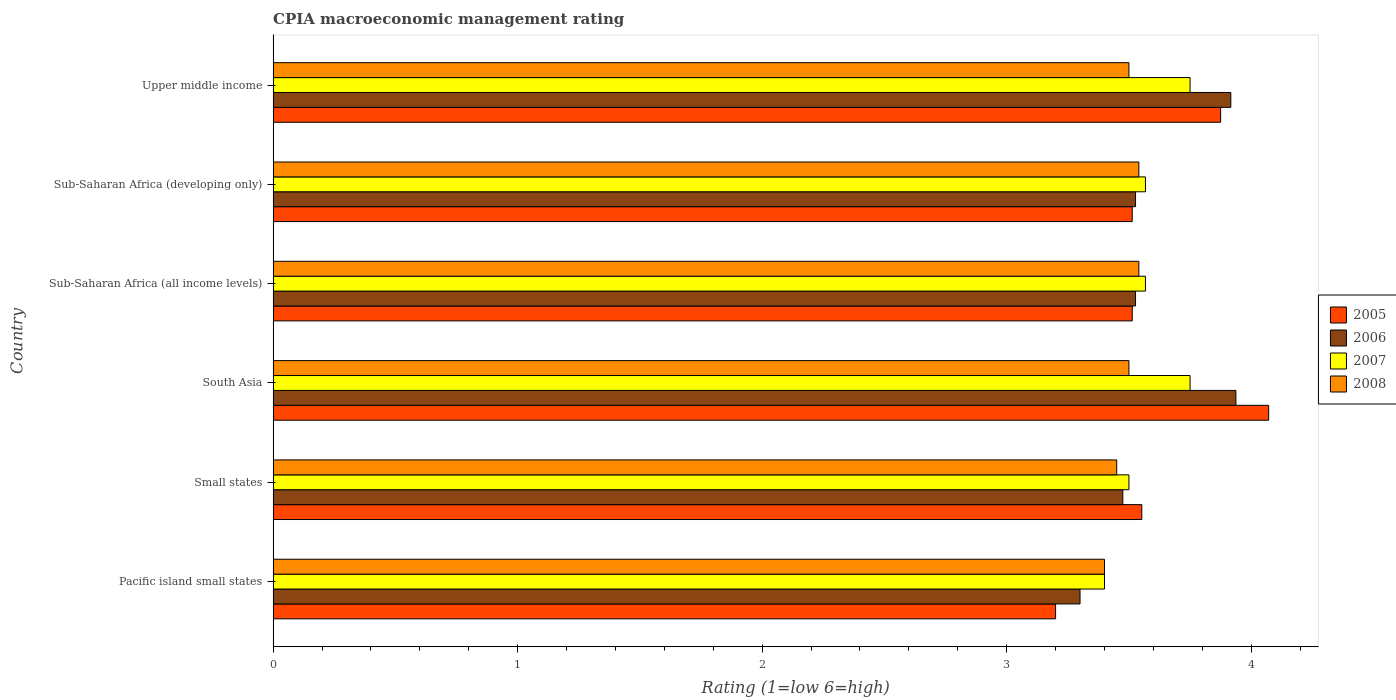How many groups of bars are there?
Keep it short and to the point. 6. Are the number of bars per tick equal to the number of legend labels?
Offer a very short reply. Yes. How many bars are there on the 3rd tick from the top?
Give a very brief answer. 4. How many bars are there on the 5th tick from the bottom?
Keep it short and to the point. 4. What is the label of the 2nd group of bars from the top?
Make the answer very short. Sub-Saharan Africa (developing only). What is the CPIA rating in 2005 in Sub-Saharan Africa (developing only)?
Ensure brevity in your answer.  3.51. Across all countries, what is the maximum CPIA rating in 2007?
Give a very brief answer. 3.75. Across all countries, what is the minimum CPIA rating in 2007?
Your answer should be compact. 3.4. In which country was the CPIA rating in 2005 maximum?
Make the answer very short. South Asia. In which country was the CPIA rating in 2005 minimum?
Ensure brevity in your answer.  Pacific island small states. What is the total CPIA rating in 2007 in the graph?
Keep it short and to the point. 21.54. What is the difference between the CPIA rating in 2005 in Sub-Saharan Africa (all income levels) and that in Upper middle income?
Give a very brief answer. -0.36. What is the difference between the CPIA rating in 2008 in Pacific island small states and the CPIA rating in 2006 in South Asia?
Your answer should be very brief. -0.54. What is the average CPIA rating in 2005 per country?
Provide a short and direct response. 3.62. What is the difference between the CPIA rating in 2007 and CPIA rating in 2006 in Small states?
Provide a succinct answer. 0.02. In how many countries, is the CPIA rating in 2008 greater than 0.6000000000000001 ?
Keep it short and to the point. 6. What is the ratio of the CPIA rating in 2006 in Sub-Saharan Africa (all income levels) to that in Upper middle income?
Provide a short and direct response. 0.9. Is the difference between the CPIA rating in 2007 in Sub-Saharan Africa (developing only) and Upper middle income greater than the difference between the CPIA rating in 2006 in Sub-Saharan Africa (developing only) and Upper middle income?
Your answer should be compact. Yes. What is the difference between the highest and the second highest CPIA rating in 2005?
Your response must be concise. 0.2. What is the difference between the highest and the lowest CPIA rating in 2006?
Make the answer very short. 0.64. In how many countries, is the CPIA rating in 2007 greater than the average CPIA rating in 2007 taken over all countries?
Ensure brevity in your answer.  2. Is the sum of the CPIA rating in 2006 in South Asia and Sub-Saharan Africa (developing only) greater than the maximum CPIA rating in 2007 across all countries?
Your answer should be compact. Yes. What does the 2nd bar from the bottom in Pacific island small states represents?
Keep it short and to the point. 2006. Are all the bars in the graph horizontal?
Ensure brevity in your answer.  Yes. What is the difference between two consecutive major ticks on the X-axis?
Ensure brevity in your answer.  1. Are the values on the major ticks of X-axis written in scientific E-notation?
Provide a short and direct response. No. Does the graph contain any zero values?
Offer a very short reply. No. Does the graph contain grids?
Provide a succinct answer. No. How are the legend labels stacked?
Provide a short and direct response. Vertical. What is the title of the graph?
Your answer should be compact. CPIA macroeconomic management rating. Does "1964" appear as one of the legend labels in the graph?
Provide a succinct answer. No. What is the label or title of the Y-axis?
Your response must be concise. Country. What is the Rating (1=low 6=high) of 2006 in Pacific island small states?
Your response must be concise. 3.3. What is the Rating (1=low 6=high) of 2008 in Pacific island small states?
Offer a terse response. 3.4. What is the Rating (1=low 6=high) of 2005 in Small states?
Provide a succinct answer. 3.55. What is the Rating (1=low 6=high) of 2006 in Small states?
Offer a very short reply. 3.48. What is the Rating (1=low 6=high) of 2008 in Small states?
Your answer should be very brief. 3.45. What is the Rating (1=low 6=high) in 2005 in South Asia?
Your answer should be compact. 4.07. What is the Rating (1=low 6=high) in 2006 in South Asia?
Provide a succinct answer. 3.94. What is the Rating (1=low 6=high) of 2007 in South Asia?
Your response must be concise. 3.75. What is the Rating (1=low 6=high) of 2005 in Sub-Saharan Africa (all income levels)?
Give a very brief answer. 3.51. What is the Rating (1=low 6=high) in 2006 in Sub-Saharan Africa (all income levels)?
Make the answer very short. 3.53. What is the Rating (1=low 6=high) in 2007 in Sub-Saharan Africa (all income levels)?
Offer a very short reply. 3.57. What is the Rating (1=low 6=high) in 2008 in Sub-Saharan Africa (all income levels)?
Provide a short and direct response. 3.54. What is the Rating (1=low 6=high) of 2005 in Sub-Saharan Africa (developing only)?
Give a very brief answer. 3.51. What is the Rating (1=low 6=high) of 2006 in Sub-Saharan Africa (developing only)?
Your answer should be very brief. 3.53. What is the Rating (1=low 6=high) in 2007 in Sub-Saharan Africa (developing only)?
Offer a terse response. 3.57. What is the Rating (1=low 6=high) in 2008 in Sub-Saharan Africa (developing only)?
Provide a succinct answer. 3.54. What is the Rating (1=low 6=high) in 2005 in Upper middle income?
Your response must be concise. 3.88. What is the Rating (1=low 6=high) of 2006 in Upper middle income?
Give a very brief answer. 3.92. What is the Rating (1=low 6=high) of 2007 in Upper middle income?
Make the answer very short. 3.75. Across all countries, what is the maximum Rating (1=low 6=high) of 2005?
Offer a terse response. 4.07. Across all countries, what is the maximum Rating (1=low 6=high) of 2006?
Your answer should be compact. 3.94. Across all countries, what is the maximum Rating (1=low 6=high) of 2007?
Your response must be concise. 3.75. Across all countries, what is the maximum Rating (1=low 6=high) in 2008?
Your answer should be very brief. 3.54. Across all countries, what is the minimum Rating (1=low 6=high) in 2008?
Give a very brief answer. 3.4. What is the total Rating (1=low 6=high) in 2005 in the graph?
Your response must be concise. 21.73. What is the total Rating (1=low 6=high) in 2006 in the graph?
Ensure brevity in your answer.  21.68. What is the total Rating (1=low 6=high) in 2007 in the graph?
Provide a short and direct response. 21.54. What is the total Rating (1=low 6=high) in 2008 in the graph?
Your answer should be very brief. 20.93. What is the difference between the Rating (1=low 6=high) of 2005 in Pacific island small states and that in Small states?
Make the answer very short. -0.35. What is the difference between the Rating (1=low 6=high) in 2006 in Pacific island small states and that in Small states?
Make the answer very short. -0.17. What is the difference between the Rating (1=low 6=high) of 2007 in Pacific island small states and that in Small states?
Your answer should be compact. -0.1. What is the difference between the Rating (1=low 6=high) in 2008 in Pacific island small states and that in Small states?
Ensure brevity in your answer.  -0.05. What is the difference between the Rating (1=low 6=high) in 2005 in Pacific island small states and that in South Asia?
Give a very brief answer. -0.87. What is the difference between the Rating (1=low 6=high) in 2006 in Pacific island small states and that in South Asia?
Ensure brevity in your answer.  -0.64. What is the difference between the Rating (1=low 6=high) in 2007 in Pacific island small states and that in South Asia?
Your answer should be very brief. -0.35. What is the difference between the Rating (1=low 6=high) in 2008 in Pacific island small states and that in South Asia?
Make the answer very short. -0.1. What is the difference between the Rating (1=low 6=high) in 2005 in Pacific island small states and that in Sub-Saharan Africa (all income levels)?
Keep it short and to the point. -0.31. What is the difference between the Rating (1=low 6=high) in 2006 in Pacific island small states and that in Sub-Saharan Africa (all income levels)?
Your answer should be compact. -0.23. What is the difference between the Rating (1=low 6=high) in 2007 in Pacific island small states and that in Sub-Saharan Africa (all income levels)?
Your response must be concise. -0.17. What is the difference between the Rating (1=low 6=high) in 2008 in Pacific island small states and that in Sub-Saharan Africa (all income levels)?
Make the answer very short. -0.14. What is the difference between the Rating (1=low 6=high) of 2005 in Pacific island small states and that in Sub-Saharan Africa (developing only)?
Your answer should be very brief. -0.31. What is the difference between the Rating (1=low 6=high) of 2006 in Pacific island small states and that in Sub-Saharan Africa (developing only)?
Your answer should be very brief. -0.23. What is the difference between the Rating (1=low 6=high) of 2007 in Pacific island small states and that in Sub-Saharan Africa (developing only)?
Offer a terse response. -0.17. What is the difference between the Rating (1=low 6=high) of 2008 in Pacific island small states and that in Sub-Saharan Africa (developing only)?
Ensure brevity in your answer.  -0.14. What is the difference between the Rating (1=low 6=high) of 2005 in Pacific island small states and that in Upper middle income?
Provide a succinct answer. -0.68. What is the difference between the Rating (1=low 6=high) of 2006 in Pacific island small states and that in Upper middle income?
Your answer should be very brief. -0.62. What is the difference between the Rating (1=low 6=high) of 2007 in Pacific island small states and that in Upper middle income?
Offer a terse response. -0.35. What is the difference between the Rating (1=low 6=high) of 2008 in Pacific island small states and that in Upper middle income?
Give a very brief answer. -0.1. What is the difference between the Rating (1=low 6=high) of 2005 in Small states and that in South Asia?
Your answer should be very brief. -0.52. What is the difference between the Rating (1=low 6=high) in 2006 in Small states and that in South Asia?
Your answer should be compact. -0.46. What is the difference between the Rating (1=low 6=high) in 2008 in Small states and that in South Asia?
Offer a terse response. -0.05. What is the difference between the Rating (1=low 6=high) in 2005 in Small states and that in Sub-Saharan Africa (all income levels)?
Provide a succinct answer. 0.04. What is the difference between the Rating (1=low 6=high) of 2006 in Small states and that in Sub-Saharan Africa (all income levels)?
Provide a short and direct response. -0.05. What is the difference between the Rating (1=low 6=high) in 2007 in Small states and that in Sub-Saharan Africa (all income levels)?
Your answer should be compact. -0.07. What is the difference between the Rating (1=low 6=high) of 2008 in Small states and that in Sub-Saharan Africa (all income levels)?
Provide a short and direct response. -0.09. What is the difference between the Rating (1=low 6=high) in 2005 in Small states and that in Sub-Saharan Africa (developing only)?
Your answer should be very brief. 0.04. What is the difference between the Rating (1=low 6=high) of 2006 in Small states and that in Sub-Saharan Africa (developing only)?
Provide a short and direct response. -0.05. What is the difference between the Rating (1=low 6=high) in 2007 in Small states and that in Sub-Saharan Africa (developing only)?
Offer a terse response. -0.07. What is the difference between the Rating (1=low 6=high) in 2008 in Small states and that in Sub-Saharan Africa (developing only)?
Give a very brief answer. -0.09. What is the difference between the Rating (1=low 6=high) of 2005 in Small states and that in Upper middle income?
Your answer should be very brief. -0.32. What is the difference between the Rating (1=low 6=high) in 2006 in Small states and that in Upper middle income?
Ensure brevity in your answer.  -0.44. What is the difference between the Rating (1=low 6=high) in 2005 in South Asia and that in Sub-Saharan Africa (all income levels)?
Provide a succinct answer. 0.56. What is the difference between the Rating (1=low 6=high) of 2006 in South Asia and that in Sub-Saharan Africa (all income levels)?
Give a very brief answer. 0.41. What is the difference between the Rating (1=low 6=high) in 2007 in South Asia and that in Sub-Saharan Africa (all income levels)?
Make the answer very short. 0.18. What is the difference between the Rating (1=low 6=high) in 2008 in South Asia and that in Sub-Saharan Africa (all income levels)?
Give a very brief answer. -0.04. What is the difference between the Rating (1=low 6=high) of 2005 in South Asia and that in Sub-Saharan Africa (developing only)?
Your answer should be very brief. 0.56. What is the difference between the Rating (1=low 6=high) of 2006 in South Asia and that in Sub-Saharan Africa (developing only)?
Provide a succinct answer. 0.41. What is the difference between the Rating (1=low 6=high) of 2007 in South Asia and that in Sub-Saharan Africa (developing only)?
Ensure brevity in your answer.  0.18. What is the difference between the Rating (1=low 6=high) of 2008 in South Asia and that in Sub-Saharan Africa (developing only)?
Offer a terse response. -0.04. What is the difference between the Rating (1=low 6=high) of 2005 in South Asia and that in Upper middle income?
Your answer should be very brief. 0.2. What is the difference between the Rating (1=low 6=high) in 2006 in South Asia and that in Upper middle income?
Keep it short and to the point. 0.02. What is the difference between the Rating (1=low 6=high) in 2008 in South Asia and that in Upper middle income?
Keep it short and to the point. 0. What is the difference between the Rating (1=low 6=high) of 2005 in Sub-Saharan Africa (all income levels) and that in Upper middle income?
Make the answer very short. -0.36. What is the difference between the Rating (1=low 6=high) in 2006 in Sub-Saharan Africa (all income levels) and that in Upper middle income?
Keep it short and to the point. -0.39. What is the difference between the Rating (1=low 6=high) of 2007 in Sub-Saharan Africa (all income levels) and that in Upper middle income?
Your answer should be very brief. -0.18. What is the difference between the Rating (1=low 6=high) of 2008 in Sub-Saharan Africa (all income levels) and that in Upper middle income?
Offer a terse response. 0.04. What is the difference between the Rating (1=low 6=high) in 2005 in Sub-Saharan Africa (developing only) and that in Upper middle income?
Make the answer very short. -0.36. What is the difference between the Rating (1=low 6=high) in 2006 in Sub-Saharan Africa (developing only) and that in Upper middle income?
Give a very brief answer. -0.39. What is the difference between the Rating (1=low 6=high) of 2007 in Sub-Saharan Africa (developing only) and that in Upper middle income?
Give a very brief answer. -0.18. What is the difference between the Rating (1=low 6=high) of 2008 in Sub-Saharan Africa (developing only) and that in Upper middle income?
Your answer should be compact. 0.04. What is the difference between the Rating (1=low 6=high) in 2005 in Pacific island small states and the Rating (1=low 6=high) in 2006 in Small states?
Ensure brevity in your answer.  -0.28. What is the difference between the Rating (1=low 6=high) of 2005 in Pacific island small states and the Rating (1=low 6=high) of 2008 in Small states?
Provide a succinct answer. -0.25. What is the difference between the Rating (1=low 6=high) of 2006 in Pacific island small states and the Rating (1=low 6=high) of 2008 in Small states?
Give a very brief answer. -0.15. What is the difference between the Rating (1=low 6=high) in 2007 in Pacific island small states and the Rating (1=low 6=high) in 2008 in Small states?
Your answer should be very brief. -0.05. What is the difference between the Rating (1=low 6=high) of 2005 in Pacific island small states and the Rating (1=low 6=high) of 2006 in South Asia?
Ensure brevity in your answer.  -0.74. What is the difference between the Rating (1=low 6=high) of 2005 in Pacific island small states and the Rating (1=low 6=high) of 2007 in South Asia?
Your answer should be very brief. -0.55. What is the difference between the Rating (1=low 6=high) in 2005 in Pacific island small states and the Rating (1=low 6=high) in 2008 in South Asia?
Your answer should be compact. -0.3. What is the difference between the Rating (1=low 6=high) in 2006 in Pacific island small states and the Rating (1=low 6=high) in 2007 in South Asia?
Offer a terse response. -0.45. What is the difference between the Rating (1=low 6=high) in 2005 in Pacific island small states and the Rating (1=low 6=high) in 2006 in Sub-Saharan Africa (all income levels)?
Offer a terse response. -0.33. What is the difference between the Rating (1=low 6=high) in 2005 in Pacific island small states and the Rating (1=low 6=high) in 2007 in Sub-Saharan Africa (all income levels)?
Offer a terse response. -0.37. What is the difference between the Rating (1=low 6=high) in 2005 in Pacific island small states and the Rating (1=low 6=high) in 2008 in Sub-Saharan Africa (all income levels)?
Give a very brief answer. -0.34. What is the difference between the Rating (1=low 6=high) of 2006 in Pacific island small states and the Rating (1=low 6=high) of 2007 in Sub-Saharan Africa (all income levels)?
Offer a terse response. -0.27. What is the difference between the Rating (1=low 6=high) of 2006 in Pacific island small states and the Rating (1=low 6=high) of 2008 in Sub-Saharan Africa (all income levels)?
Ensure brevity in your answer.  -0.24. What is the difference between the Rating (1=low 6=high) in 2007 in Pacific island small states and the Rating (1=low 6=high) in 2008 in Sub-Saharan Africa (all income levels)?
Offer a very short reply. -0.14. What is the difference between the Rating (1=low 6=high) in 2005 in Pacific island small states and the Rating (1=low 6=high) in 2006 in Sub-Saharan Africa (developing only)?
Give a very brief answer. -0.33. What is the difference between the Rating (1=low 6=high) in 2005 in Pacific island small states and the Rating (1=low 6=high) in 2007 in Sub-Saharan Africa (developing only)?
Provide a succinct answer. -0.37. What is the difference between the Rating (1=low 6=high) in 2005 in Pacific island small states and the Rating (1=low 6=high) in 2008 in Sub-Saharan Africa (developing only)?
Offer a terse response. -0.34. What is the difference between the Rating (1=low 6=high) in 2006 in Pacific island small states and the Rating (1=low 6=high) in 2007 in Sub-Saharan Africa (developing only)?
Your answer should be compact. -0.27. What is the difference between the Rating (1=low 6=high) of 2006 in Pacific island small states and the Rating (1=low 6=high) of 2008 in Sub-Saharan Africa (developing only)?
Ensure brevity in your answer.  -0.24. What is the difference between the Rating (1=low 6=high) of 2007 in Pacific island small states and the Rating (1=low 6=high) of 2008 in Sub-Saharan Africa (developing only)?
Provide a succinct answer. -0.14. What is the difference between the Rating (1=low 6=high) of 2005 in Pacific island small states and the Rating (1=low 6=high) of 2006 in Upper middle income?
Keep it short and to the point. -0.72. What is the difference between the Rating (1=low 6=high) of 2005 in Pacific island small states and the Rating (1=low 6=high) of 2007 in Upper middle income?
Give a very brief answer. -0.55. What is the difference between the Rating (1=low 6=high) in 2006 in Pacific island small states and the Rating (1=low 6=high) in 2007 in Upper middle income?
Ensure brevity in your answer.  -0.45. What is the difference between the Rating (1=low 6=high) in 2006 in Pacific island small states and the Rating (1=low 6=high) in 2008 in Upper middle income?
Provide a short and direct response. -0.2. What is the difference between the Rating (1=low 6=high) of 2005 in Small states and the Rating (1=low 6=high) of 2006 in South Asia?
Your response must be concise. -0.38. What is the difference between the Rating (1=low 6=high) in 2005 in Small states and the Rating (1=low 6=high) in 2007 in South Asia?
Make the answer very short. -0.2. What is the difference between the Rating (1=low 6=high) in 2005 in Small states and the Rating (1=low 6=high) in 2008 in South Asia?
Your answer should be very brief. 0.05. What is the difference between the Rating (1=low 6=high) in 2006 in Small states and the Rating (1=low 6=high) in 2007 in South Asia?
Provide a short and direct response. -0.28. What is the difference between the Rating (1=low 6=high) of 2006 in Small states and the Rating (1=low 6=high) of 2008 in South Asia?
Offer a very short reply. -0.03. What is the difference between the Rating (1=low 6=high) in 2007 in Small states and the Rating (1=low 6=high) in 2008 in South Asia?
Provide a short and direct response. 0. What is the difference between the Rating (1=low 6=high) in 2005 in Small states and the Rating (1=low 6=high) in 2006 in Sub-Saharan Africa (all income levels)?
Your response must be concise. 0.03. What is the difference between the Rating (1=low 6=high) in 2005 in Small states and the Rating (1=low 6=high) in 2007 in Sub-Saharan Africa (all income levels)?
Provide a short and direct response. -0.01. What is the difference between the Rating (1=low 6=high) in 2005 in Small states and the Rating (1=low 6=high) in 2008 in Sub-Saharan Africa (all income levels)?
Keep it short and to the point. 0.01. What is the difference between the Rating (1=low 6=high) of 2006 in Small states and the Rating (1=low 6=high) of 2007 in Sub-Saharan Africa (all income levels)?
Offer a very short reply. -0.09. What is the difference between the Rating (1=low 6=high) of 2006 in Small states and the Rating (1=low 6=high) of 2008 in Sub-Saharan Africa (all income levels)?
Ensure brevity in your answer.  -0.07. What is the difference between the Rating (1=low 6=high) of 2007 in Small states and the Rating (1=low 6=high) of 2008 in Sub-Saharan Africa (all income levels)?
Provide a succinct answer. -0.04. What is the difference between the Rating (1=low 6=high) of 2005 in Small states and the Rating (1=low 6=high) of 2006 in Sub-Saharan Africa (developing only)?
Keep it short and to the point. 0.03. What is the difference between the Rating (1=low 6=high) of 2005 in Small states and the Rating (1=low 6=high) of 2007 in Sub-Saharan Africa (developing only)?
Give a very brief answer. -0.01. What is the difference between the Rating (1=low 6=high) in 2005 in Small states and the Rating (1=low 6=high) in 2008 in Sub-Saharan Africa (developing only)?
Offer a terse response. 0.01. What is the difference between the Rating (1=low 6=high) of 2006 in Small states and the Rating (1=low 6=high) of 2007 in Sub-Saharan Africa (developing only)?
Provide a short and direct response. -0.09. What is the difference between the Rating (1=low 6=high) of 2006 in Small states and the Rating (1=low 6=high) of 2008 in Sub-Saharan Africa (developing only)?
Provide a short and direct response. -0.07. What is the difference between the Rating (1=low 6=high) in 2007 in Small states and the Rating (1=low 6=high) in 2008 in Sub-Saharan Africa (developing only)?
Provide a succinct answer. -0.04. What is the difference between the Rating (1=low 6=high) of 2005 in Small states and the Rating (1=low 6=high) of 2006 in Upper middle income?
Ensure brevity in your answer.  -0.36. What is the difference between the Rating (1=low 6=high) in 2005 in Small states and the Rating (1=low 6=high) in 2007 in Upper middle income?
Provide a succinct answer. -0.2. What is the difference between the Rating (1=low 6=high) of 2005 in Small states and the Rating (1=low 6=high) of 2008 in Upper middle income?
Your answer should be very brief. 0.05. What is the difference between the Rating (1=low 6=high) of 2006 in Small states and the Rating (1=low 6=high) of 2007 in Upper middle income?
Provide a succinct answer. -0.28. What is the difference between the Rating (1=low 6=high) in 2006 in Small states and the Rating (1=low 6=high) in 2008 in Upper middle income?
Give a very brief answer. -0.03. What is the difference between the Rating (1=low 6=high) of 2007 in Small states and the Rating (1=low 6=high) of 2008 in Upper middle income?
Ensure brevity in your answer.  0. What is the difference between the Rating (1=low 6=high) of 2005 in South Asia and the Rating (1=low 6=high) of 2006 in Sub-Saharan Africa (all income levels)?
Offer a very short reply. 0.54. What is the difference between the Rating (1=low 6=high) in 2005 in South Asia and the Rating (1=low 6=high) in 2007 in Sub-Saharan Africa (all income levels)?
Your answer should be very brief. 0.5. What is the difference between the Rating (1=low 6=high) of 2005 in South Asia and the Rating (1=low 6=high) of 2008 in Sub-Saharan Africa (all income levels)?
Ensure brevity in your answer.  0.53. What is the difference between the Rating (1=low 6=high) in 2006 in South Asia and the Rating (1=low 6=high) in 2007 in Sub-Saharan Africa (all income levels)?
Ensure brevity in your answer.  0.37. What is the difference between the Rating (1=low 6=high) in 2006 in South Asia and the Rating (1=low 6=high) in 2008 in Sub-Saharan Africa (all income levels)?
Give a very brief answer. 0.4. What is the difference between the Rating (1=low 6=high) of 2007 in South Asia and the Rating (1=low 6=high) of 2008 in Sub-Saharan Africa (all income levels)?
Offer a terse response. 0.21. What is the difference between the Rating (1=low 6=high) in 2005 in South Asia and the Rating (1=low 6=high) in 2006 in Sub-Saharan Africa (developing only)?
Keep it short and to the point. 0.54. What is the difference between the Rating (1=low 6=high) of 2005 in South Asia and the Rating (1=low 6=high) of 2007 in Sub-Saharan Africa (developing only)?
Offer a very short reply. 0.5. What is the difference between the Rating (1=low 6=high) in 2005 in South Asia and the Rating (1=low 6=high) in 2008 in Sub-Saharan Africa (developing only)?
Offer a very short reply. 0.53. What is the difference between the Rating (1=low 6=high) of 2006 in South Asia and the Rating (1=low 6=high) of 2007 in Sub-Saharan Africa (developing only)?
Your response must be concise. 0.37. What is the difference between the Rating (1=low 6=high) in 2006 in South Asia and the Rating (1=low 6=high) in 2008 in Sub-Saharan Africa (developing only)?
Ensure brevity in your answer.  0.4. What is the difference between the Rating (1=low 6=high) in 2007 in South Asia and the Rating (1=low 6=high) in 2008 in Sub-Saharan Africa (developing only)?
Provide a short and direct response. 0.21. What is the difference between the Rating (1=low 6=high) in 2005 in South Asia and the Rating (1=low 6=high) in 2006 in Upper middle income?
Give a very brief answer. 0.15. What is the difference between the Rating (1=low 6=high) in 2005 in South Asia and the Rating (1=low 6=high) in 2007 in Upper middle income?
Make the answer very short. 0.32. What is the difference between the Rating (1=low 6=high) in 2005 in South Asia and the Rating (1=low 6=high) in 2008 in Upper middle income?
Your answer should be very brief. 0.57. What is the difference between the Rating (1=low 6=high) in 2006 in South Asia and the Rating (1=low 6=high) in 2007 in Upper middle income?
Make the answer very short. 0.19. What is the difference between the Rating (1=low 6=high) in 2006 in South Asia and the Rating (1=low 6=high) in 2008 in Upper middle income?
Your response must be concise. 0.44. What is the difference between the Rating (1=low 6=high) in 2007 in South Asia and the Rating (1=low 6=high) in 2008 in Upper middle income?
Offer a very short reply. 0.25. What is the difference between the Rating (1=low 6=high) of 2005 in Sub-Saharan Africa (all income levels) and the Rating (1=low 6=high) of 2006 in Sub-Saharan Africa (developing only)?
Offer a terse response. -0.01. What is the difference between the Rating (1=low 6=high) of 2005 in Sub-Saharan Africa (all income levels) and the Rating (1=low 6=high) of 2007 in Sub-Saharan Africa (developing only)?
Offer a very short reply. -0.05. What is the difference between the Rating (1=low 6=high) in 2005 in Sub-Saharan Africa (all income levels) and the Rating (1=low 6=high) in 2008 in Sub-Saharan Africa (developing only)?
Provide a succinct answer. -0.03. What is the difference between the Rating (1=low 6=high) in 2006 in Sub-Saharan Africa (all income levels) and the Rating (1=low 6=high) in 2007 in Sub-Saharan Africa (developing only)?
Your response must be concise. -0.04. What is the difference between the Rating (1=low 6=high) in 2006 in Sub-Saharan Africa (all income levels) and the Rating (1=low 6=high) in 2008 in Sub-Saharan Africa (developing only)?
Your answer should be compact. -0.01. What is the difference between the Rating (1=low 6=high) of 2007 in Sub-Saharan Africa (all income levels) and the Rating (1=low 6=high) of 2008 in Sub-Saharan Africa (developing only)?
Your answer should be compact. 0.03. What is the difference between the Rating (1=low 6=high) in 2005 in Sub-Saharan Africa (all income levels) and the Rating (1=low 6=high) in 2006 in Upper middle income?
Ensure brevity in your answer.  -0.4. What is the difference between the Rating (1=low 6=high) of 2005 in Sub-Saharan Africa (all income levels) and the Rating (1=low 6=high) of 2007 in Upper middle income?
Offer a very short reply. -0.24. What is the difference between the Rating (1=low 6=high) of 2005 in Sub-Saharan Africa (all income levels) and the Rating (1=low 6=high) of 2008 in Upper middle income?
Your response must be concise. 0.01. What is the difference between the Rating (1=low 6=high) in 2006 in Sub-Saharan Africa (all income levels) and the Rating (1=low 6=high) in 2007 in Upper middle income?
Make the answer very short. -0.22. What is the difference between the Rating (1=low 6=high) of 2006 in Sub-Saharan Africa (all income levels) and the Rating (1=low 6=high) of 2008 in Upper middle income?
Offer a very short reply. 0.03. What is the difference between the Rating (1=low 6=high) of 2007 in Sub-Saharan Africa (all income levels) and the Rating (1=low 6=high) of 2008 in Upper middle income?
Offer a terse response. 0.07. What is the difference between the Rating (1=low 6=high) of 2005 in Sub-Saharan Africa (developing only) and the Rating (1=low 6=high) of 2006 in Upper middle income?
Keep it short and to the point. -0.4. What is the difference between the Rating (1=low 6=high) of 2005 in Sub-Saharan Africa (developing only) and the Rating (1=low 6=high) of 2007 in Upper middle income?
Provide a succinct answer. -0.24. What is the difference between the Rating (1=low 6=high) of 2005 in Sub-Saharan Africa (developing only) and the Rating (1=low 6=high) of 2008 in Upper middle income?
Make the answer very short. 0.01. What is the difference between the Rating (1=low 6=high) in 2006 in Sub-Saharan Africa (developing only) and the Rating (1=low 6=high) in 2007 in Upper middle income?
Your response must be concise. -0.22. What is the difference between the Rating (1=low 6=high) in 2006 in Sub-Saharan Africa (developing only) and the Rating (1=low 6=high) in 2008 in Upper middle income?
Offer a terse response. 0.03. What is the difference between the Rating (1=low 6=high) in 2007 in Sub-Saharan Africa (developing only) and the Rating (1=low 6=high) in 2008 in Upper middle income?
Provide a succinct answer. 0.07. What is the average Rating (1=low 6=high) in 2005 per country?
Make the answer very short. 3.62. What is the average Rating (1=low 6=high) in 2006 per country?
Your answer should be compact. 3.61. What is the average Rating (1=low 6=high) in 2007 per country?
Keep it short and to the point. 3.59. What is the average Rating (1=low 6=high) in 2008 per country?
Keep it short and to the point. 3.49. What is the difference between the Rating (1=low 6=high) of 2005 and Rating (1=low 6=high) of 2007 in Pacific island small states?
Keep it short and to the point. -0.2. What is the difference between the Rating (1=low 6=high) in 2005 and Rating (1=low 6=high) in 2008 in Pacific island small states?
Give a very brief answer. -0.2. What is the difference between the Rating (1=low 6=high) of 2006 and Rating (1=low 6=high) of 2008 in Pacific island small states?
Offer a terse response. -0.1. What is the difference between the Rating (1=low 6=high) of 2005 and Rating (1=low 6=high) of 2006 in Small states?
Your response must be concise. 0.08. What is the difference between the Rating (1=low 6=high) of 2005 and Rating (1=low 6=high) of 2007 in Small states?
Ensure brevity in your answer.  0.05. What is the difference between the Rating (1=low 6=high) of 2005 and Rating (1=low 6=high) of 2008 in Small states?
Provide a succinct answer. 0.1. What is the difference between the Rating (1=low 6=high) in 2006 and Rating (1=low 6=high) in 2007 in Small states?
Make the answer very short. -0.03. What is the difference between the Rating (1=low 6=high) of 2006 and Rating (1=low 6=high) of 2008 in Small states?
Offer a very short reply. 0.03. What is the difference between the Rating (1=low 6=high) in 2007 and Rating (1=low 6=high) in 2008 in Small states?
Make the answer very short. 0.05. What is the difference between the Rating (1=low 6=high) of 2005 and Rating (1=low 6=high) of 2006 in South Asia?
Give a very brief answer. 0.13. What is the difference between the Rating (1=low 6=high) in 2005 and Rating (1=low 6=high) in 2007 in South Asia?
Ensure brevity in your answer.  0.32. What is the difference between the Rating (1=low 6=high) of 2006 and Rating (1=low 6=high) of 2007 in South Asia?
Provide a short and direct response. 0.19. What is the difference between the Rating (1=low 6=high) of 2006 and Rating (1=low 6=high) of 2008 in South Asia?
Give a very brief answer. 0.44. What is the difference between the Rating (1=low 6=high) in 2005 and Rating (1=low 6=high) in 2006 in Sub-Saharan Africa (all income levels)?
Give a very brief answer. -0.01. What is the difference between the Rating (1=low 6=high) of 2005 and Rating (1=low 6=high) of 2007 in Sub-Saharan Africa (all income levels)?
Provide a succinct answer. -0.05. What is the difference between the Rating (1=low 6=high) of 2005 and Rating (1=low 6=high) of 2008 in Sub-Saharan Africa (all income levels)?
Make the answer very short. -0.03. What is the difference between the Rating (1=low 6=high) in 2006 and Rating (1=low 6=high) in 2007 in Sub-Saharan Africa (all income levels)?
Make the answer very short. -0.04. What is the difference between the Rating (1=low 6=high) in 2006 and Rating (1=low 6=high) in 2008 in Sub-Saharan Africa (all income levels)?
Your answer should be compact. -0.01. What is the difference between the Rating (1=low 6=high) in 2007 and Rating (1=low 6=high) in 2008 in Sub-Saharan Africa (all income levels)?
Provide a succinct answer. 0.03. What is the difference between the Rating (1=low 6=high) in 2005 and Rating (1=low 6=high) in 2006 in Sub-Saharan Africa (developing only)?
Give a very brief answer. -0.01. What is the difference between the Rating (1=low 6=high) in 2005 and Rating (1=low 6=high) in 2007 in Sub-Saharan Africa (developing only)?
Your answer should be compact. -0.05. What is the difference between the Rating (1=low 6=high) of 2005 and Rating (1=low 6=high) of 2008 in Sub-Saharan Africa (developing only)?
Ensure brevity in your answer.  -0.03. What is the difference between the Rating (1=low 6=high) in 2006 and Rating (1=low 6=high) in 2007 in Sub-Saharan Africa (developing only)?
Make the answer very short. -0.04. What is the difference between the Rating (1=low 6=high) in 2006 and Rating (1=low 6=high) in 2008 in Sub-Saharan Africa (developing only)?
Ensure brevity in your answer.  -0.01. What is the difference between the Rating (1=low 6=high) of 2007 and Rating (1=low 6=high) of 2008 in Sub-Saharan Africa (developing only)?
Give a very brief answer. 0.03. What is the difference between the Rating (1=low 6=high) in 2005 and Rating (1=low 6=high) in 2006 in Upper middle income?
Make the answer very short. -0.04. What is the difference between the Rating (1=low 6=high) of 2005 and Rating (1=low 6=high) of 2007 in Upper middle income?
Your answer should be compact. 0.12. What is the difference between the Rating (1=low 6=high) of 2006 and Rating (1=low 6=high) of 2007 in Upper middle income?
Keep it short and to the point. 0.17. What is the difference between the Rating (1=low 6=high) of 2006 and Rating (1=low 6=high) of 2008 in Upper middle income?
Your response must be concise. 0.42. What is the difference between the Rating (1=low 6=high) of 2007 and Rating (1=low 6=high) of 2008 in Upper middle income?
Offer a terse response. 0.25. What is the ratio of the Rating (1=low 6=high) in 2005 in Pacific island small states to that in Small states?
Offer a terse response. 0.9. What is the ratio of the Rating (1=low 6=high) in 2006 in Pacific island small states to that in Small states?
Your answer should be compact. 0.95. What is the ratio of the Rating (1=low 6=high) in 2007 in Pacific island small states to that in Small states?
Ensure brevity in your answer.  0.97. What is the ratio of the Rating (1=low 6=high) in 2008 in Pacific island small states to that in Small states?
Provide a short and direct response. 0.99. What is the ratio of the Rating (1=low 6=high) in 2005 in Pacific island small states to that in South Asia?
Give a very brief answer. 0.79. What is the ratio of the Rating (1=low 6=high) of 2006 in Pacific island small states to that in South Asia?
Ensure brevity in your answer.  0.84. What is the ratio of the Rating (1=low 6=high) in 2007 in Pacific island small states to that in South Asia?
Provide a succinct answer. 0.91. What is the ratio of the Rating (1=low 6=high) of 2008 in Pacific island small states to that in South Asia?
Offer a very short reply. 0.97. What is the ratio of the Rating (1=low 6=high) in 2005 in Pacific island small states to that in Sub-Saharan Africa (all income levels)?
Provide a short and direct response. 0.91. What is the ratio of the Rating (1=low 6=high) of 2006 in Pacific island small states to that in Sub-Saharan Africa (all income levels)?
Give a very brief answer. 0.94. What is the ratio of the Rating (1=low 6=high) in 2007 in Pacific island small states to that in Sub-Saharan Africa (all income levels)?
Offer a very short reply. 0.95. What is the ratio of the Rating (1=low 6=high) in 2008 in Pacific island small states to that in Sub-Saharan Africa (all income levels)?
Ensure brevity in your answer.  0.96. What is the ratio of the Rating (1=low 6=high) in 2005 in Pacific island small states to that in Sub-Saharan Africa (developing only)?
Make the answer very short. 0.91. What is the ratio of the Rating (1=low 6=high) of 2006 in Pacific island small states to that in Sub-Saharan Africa (developing only)?
Your answer should be very brief. 0.94. What is the ratio of the Rating (1=low 6=high) of 2007 in Pacific island small states to that in Sub-Saharan Africa (developing only)?
Offer a terse response. 0.95. What is the ratio of the Rating (1=low 6=high) of 2008 in Pacific island small states to that in Sub-Saharan Africa (developing only)?
Offer a terse response. 0.96. What is the ratio of the Rating (1=low 6=high) of 2005 in Pacific island small states to that in Upper middle income?
Provide a short and direct response. 0.83. What is the ratio of the Rating (1=low 6=high) in 2006 in Pacific island small states to that in Upper middle income?
Keep it short and to the point. 0.84. What is the ratio of the Rating (1=low 6=high) in 2007 in Pacific island small states to that in Upper middle income?
Provide a succinct answer. 0.91. What is the ratio of the Rating (1=low 6=high) of 2008 in Pacific island small states to that in Upper middle income?
Give a very brief answer. 0.97. What is the ratio of the Rating (1=low 6=high) of 2005 in Small states to that in South Asia?
Provide a succinct answer. 0.87. What is the ratio of the Rating (1=low 6=high) in 2006 in Small states to that in South Asia?
Provide a succinct answer. 0.88. What is the ratio of the Rating (1=low 6=high) in 2008 in Small states to that in South Asia?
Make the answer very short. 0.99. What is the ratio of the Rating (1=low 6=high) of 2005 in Small states to that in Sub-Saharan Africa (all income levels)?
Your answer should be compact. 1.01. What is the ratio of the Rating (1=low 6=high) of 2006 in Small states to that in Sub-Saharan Africa (all income levels)?
Keep it short and to the point. 0.99. What is the ratio of the Rating (1=low 6=high) of 2007 in Small states to that in Sub-Saharan Africa (all income levels)?
Provide a succinct answer. 0.98. What is the ratio of the Rating (1=low 6=high) of 2008 in Small states to that in Sub-Saharan Africa (all income levels)?
Keep it short and to the point. 0.97. What is the ratio of the Rating (1=low 6=high) in 2005 in Small states to that in Sub-Saharan Africa (developing only)?
Provide a short and direct response. 1.01. What is the ratio of the Rating (1=low 6=high) in 2006 in Small states to that in Sub-Saharan Africa (developing only)?
Provide a short and direct response. 0.99. What is the ratio of the Rating (1=low 6=high) of 2007 in Small states to that in Sub-Saharan Africa (developing only)?
Keep it short and to the point. 0.98. What is the ratio of the Rating (1=low 6=high) of 2008 in Small states to that in Sub-Saharan Africa (developing only)?
Your answer should be very brief. 0.97. What is the ratio of the Rating (1=low 6=high) in 2005 in Small states to that in Upper middle income?
Provide a succinct answer. 0.92. What is the ratio of the Rating (1=low 6=high) of 2006 in Small states to that in Upper middle income?
Offer a very short reply. 0.89. What is the ratio of the Rating (1=low 6=high) in 2008 in Small states to that in Upper middle income?
Make the answer very short. 0.99. What is the ratio of the Rating (1=low 6=high) in 2005 in South Asia to that in Sub-Saharan Africa (all income levels)?
Your answer should be compact. 1.16. What is the ratio of the Rating (1=low 6=high) in 2006 in South Asia to that in Sub-Saharan Africa (all income levels)?
Offer a very short reply. 1.12. What is the ratio of the Rating (1=low 6=high) of 2007 in South Asia to that in Sub-Saharan Africa (all income levels)?
Make the answer very short. 1.05. What is the ratio of the Rating (1=low 6=high) of 2005 in South Asia to that in Sub-Saharan Africa (developing only)?
Keep it short and to the point. 1.16. What is the ratio of the Rating (1=low 6=high) of 2006 in South Asia to that in Sub-Saharan Africa (developing only)?
Your response must be concise. 1.12. What is the ratio of the Rating (1=low 6=high) in 2007 in South Asia to that in Sub-Saharan Africa (developing only)?
Give a very brief answer. 1.05. What is the ratio of the Rating (1=low 6=high) of 2008 in South Asia to that in Sub-Saharan Africa (developing only)?
Provide a short and direct response. 0.99. What is the ratio of the Rating (1=low 6=high) of 2005 in South Asia to that in Upper middle income?
Offer a terse response. 1.05. What is the ratio of the Rating (1=low 6=high) in 2006 in Sub-Saharan Africa (all income levels) to that in Sub-Saharan Africa (developing only)?
Keep it short and to the point. 1. What is the ratio of the Rating (1=low 6=high) of 2008 in Sub-Saharan Africa (all income levels) to that in Sub-Saharan Africa (developing only)?
Your answer should be very brief. 1. What is the ratio of the Rating (1=low 6=high) of 2005 in Sub-Saharan Africa (all income levels) to that in Upper middle income?
Offer a terse response. 0.91. What is the ratio of the Rating (1=low 6=high) in 2006 in Sub-Saharan Africa (all income levels) to that in Upper middle income?
Your answer should be compact. 0.9. What is the ratio of the Rating (1=low 6=high) of 2007 in Sub-Saharan Africa (all income levels) to that in Upper middle income?
Offer a terse response. 0.95. What is the ratio of the Rating (1=low 6=high) of 2008 in Sub-Saharan Africa (all income levels) to that in Upper middle income?
Your response must be concise. 1.01. What is the ratio of the Rating (1=low 6=high) of 2005 in Sub-Saharan Africa (developing only) to that in Upper middle income?
Make the answer very short. 0.91. What is the ratio of the Rating (1=low 6=high) in 2006 in Sub-Saharan Africa (developing only) to that in Upper middle income?
Keep it short and to the point. 0.9. What is the ratio of the Rating (1=low 6=high) in 2007 in Sub-Saharan Africa (developing only) to that in Upper middle income?
Your response must be concise. 0.95. What is the ratio of the Rating (1=low 6=high) of 2008 in Sub-Saharan Africa (developing only) to that in Upper middle income?
Provide a short and direct response. 1.01. What is the difference between the highest and the second highest Rating (1=low 6=high) of 2005?
Provide a short and direct response. 0.2. What is the difference between the highest and the second highest Rating (1=low 6=high) in 2006?
Provide a short and direct response. 0.02. What is the difference between the highest and the second highest Rating (1=low 6=high) in 2007?
Your answer should be compact. 0. What is the difference between the highest and the second highest Rating (1=low 6=high) in 2008?
Keep it short and to the point. 0. What is the difference between the highest and the lowest Rating (1=low 6=high) of 2005?
Offer a very short reply. 0.87. What is the difference between the highest and the lowest Rating (1=low 6=high) of 2006?
Keep it short and to the point. 0.64. What is the difference between the highest and the lowest Rating (1=low 6=high) of 2007?
Provide a succinct answer. 0.35. What is the difference between the highest and the lowest Rating (1=low 6=high) of 2008?
Your answer should be compact. 0.14. 